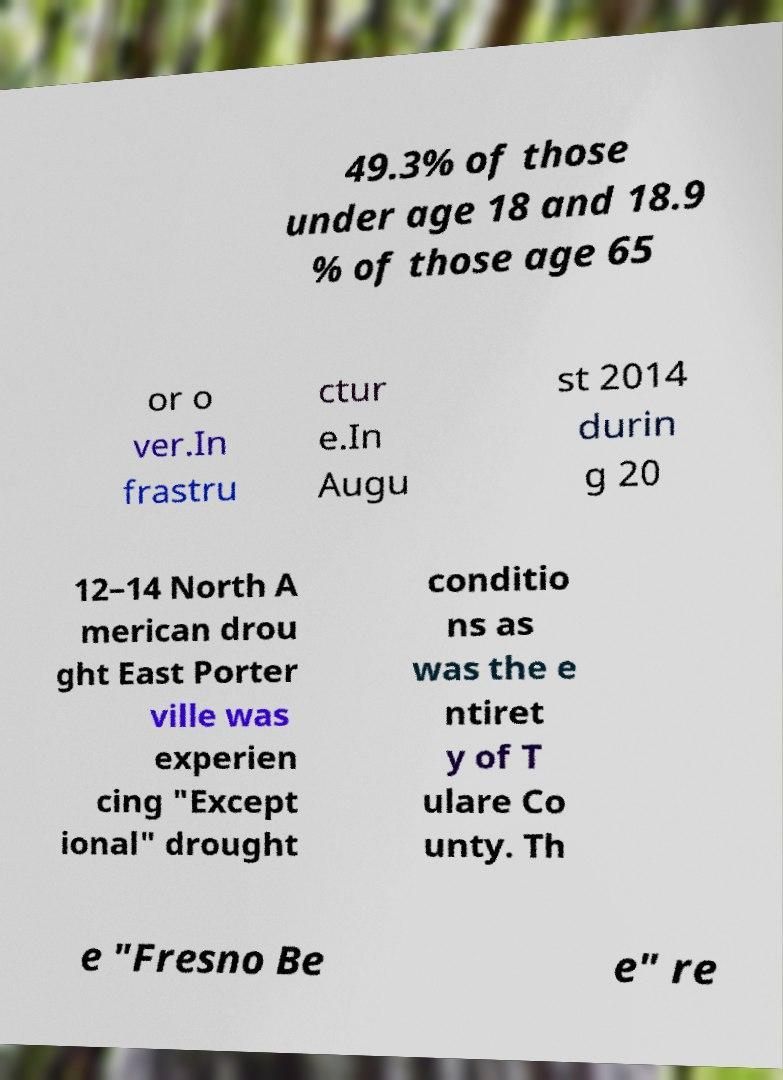I need the written content from this picture converted into text. Can you do that? 49.3% of those under age 18 and 18.9 % of those age 65 or o ver.In frastru ctur e.In Augu st 2014 durin g 20 12–14 North A merican drou ght East Porter ville was experien cing "Except ional" drought conditio ns as was the e ntiret y of T ulare Co unty. Th e "Fresno Be e" re 